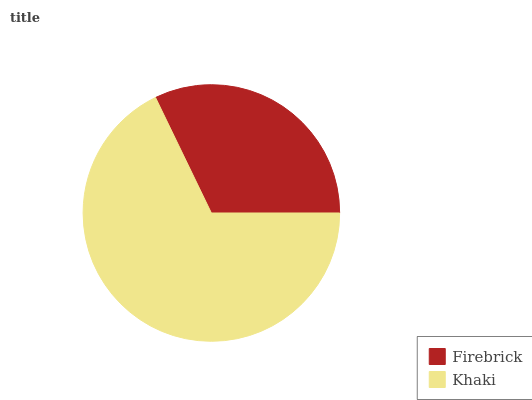Is Firebrick the minimum?
Answer yes or no. Yes. Is Khaki the maximum?
Answer yes or no. Yes. Is Khaki the minimum?
Answer yes or no. No. Is Khaki greater than Firebrick?
Answer yes or no. Yes. Is Firebrick less than Khaki?
Answer yes or no. Yes. Is Firebrick greater than Khaki?
Answer yes or no. No. Is Khaki less than Firebrick?
Answer yes or no. No. Is Khaki the high median?
Answer yes or no. Yes. Is Firebrick the low median?
Answer yes or no. Yes. Is Firebrick the high median?
Answer yes or no. No. Is Khaki the low median?
Answer yes or no. No. 